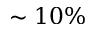Convert formula to latex. <formula><loc_0><loc_0><loc_500><loc_500>\sim 1 0 \%</formula> 